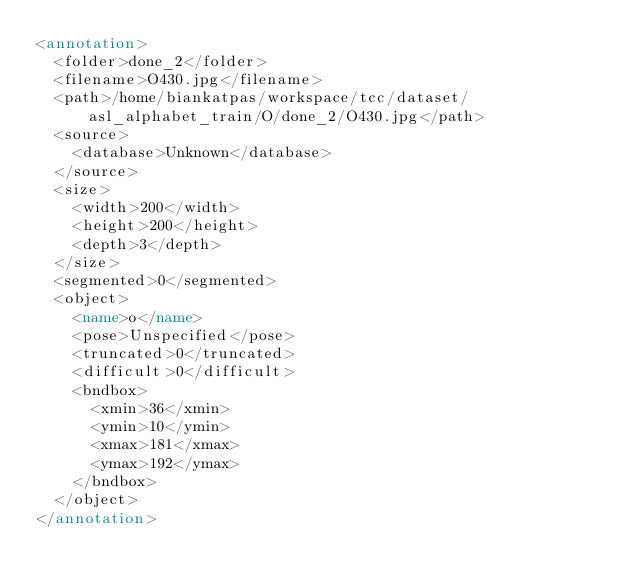Convert code to text. <code><loc_0><loc_0><loc_500><loc_500><_XML_><annotation>
	<folder>done_2</folder>
	<filename>O430.jpg</filename>
	<path>/home/biankatpas/workspace/tcc/dataset/asl_alphabet_train/O/done_2/O430.jpg</path>
	<source>
		<database>Unknown</database>
	</source>
	<size>
		<width>200</width>
		<height>200</height>
		<depth>3</depth>
	</size>
	<segmented>0</segmented>
	<object>
		<name>o</name>
		<pose>Unspecified</pose>
		<truncated>0</truncated>
		<difficult>0</difficult>
		<bndbox>
			<xmin>36</xmin>
			<ymin>10</ymin>
			<xmax>181</xmax>
			<ymax>192</ymax>
		</bndbox>
	</object>
</annotation>
</code> 